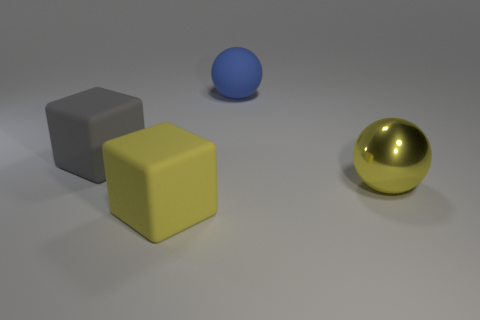Add 4 large blue metallic cubes. How many objects exist? 8 Subtract 0 green cylinders. How many objects are left? 4 Subtract 2 balls. How many balls are left? 0 Subtract all brown cubes. Subtract all yellow cylinders. How many cubes are left? 2 Subtract all gray cubes. How many yellow spheres are left? 1 Subtract all tiny green matte blocks. Subtract all large rubber cubes. How many objects are left? 2 Add 4 blue rubber spheres. How many blue rubber spheres are left? 5 Add 4 small purple rubber cubes. How many small purple rubber cubes exist? 4 Subtract all blue balls. How many balls are left? 1 